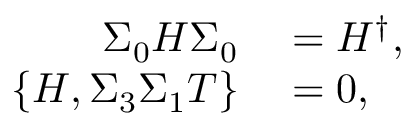Convert formula to latex. <formula><loc_0><loc_0><loc_500><loc_500>\begin{array} { r l } { \Sigma _ { 0 } H \Sigma _ { 0 } } & = H ^ { \dagger } , } \\ { \{ H , \Sigma _ { 3 } \Sigma _ { 1 } T \} } & = 0 , } \end{array}</formula> 